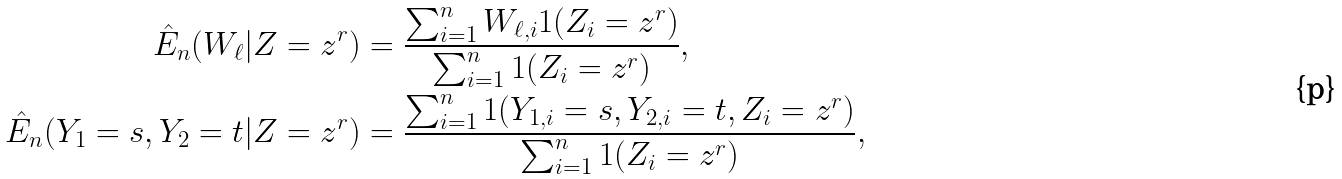Convert formula to latex. <formula><loc_0><loc_0><loc_500><loc_500>\hat { E } _ { n } ( W _ { \ell } | Z = z ^ { r } ) & = \frac { \sum _ { i = 1 } ^ { n } W _ { \ell , i } 1 ( Z _ { i } = z ^ { r } ) } { \sum _ { i = 1 } ^ { n } 1 ( Z _ { i } = z ^ { r } ) } , \\ \hat { E } _ { n } ( Y _ { 1 } = s , Y _ { 2 } = t | Z = z ^ { r } ) & = \frac { \sum _ { i = 1 } ^ { n } 1 ( Y _ { 1 , i } = s , Y _ { 2 , i } = t , Z _ { i } = z ^ { r } ) } { \sum _ { i = 1 } ^ { n } 1 ( Z _ { i } = z ^ { r } ) } ,</formula> 